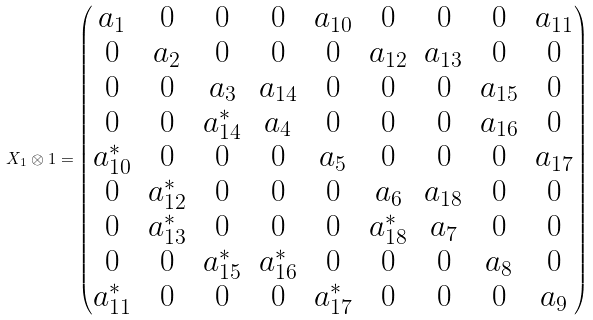<formula> <loc_0><loc_0><loc_500><loc_500>X _ { 1 } \otimes 1 = \begin{pmatrix} a _ { 1 } & 0 & 0 & 0 & a _ { 1 0 } & 0 & 0 & 0 & a _ { 1 1 } \\ 0 & a _ { 2 } & 0 & 0 & 0 & a _ { 1 2 } & a _ { 1 3 } & 0 & 0 \\ 0 & 0 & a _ { 3 } & a _ { 1 4 } & 0 & 0 & 0 & a _ { 1 5 } & 0 \\ 0 & 0 & a _ { 1 4 } ^ { * } & a _ { 4 } & 0 & 0 & 0 & a _ { 1 6 } & 0 \\ a _ { 1 0 } ^ { * } & 0 & 0 & 0 & a _ { 5 } & 0 & 0 & 0 & a _ { 1 7 } \\ 0 & a _ { 1 2 } ^ { * } & 0 & 0 & 0 & a _ { 6 } & a _ { 1 8 } & 0 & 0 \\ 0 & a _ { 1 3 } ^ { * } & 0 & 0 & 0 & a _ { 1 8 } ^ { * } & a _ { 7 } & 0 & 0 \\ 0 & 0 & a _ { 1 5 } ^ { * } & a _ { 1 6 } ^ { * } & 0 & 0 & 0 & a _ { 8 } & 0 \\ a _ { 1 1 } ^ { * } & 0 & 0 & 0 & a _ { 1 7 } ^ { * } & 0 & 0 & 0 & a _ { 9 } \end{pmatrix}</formula> 